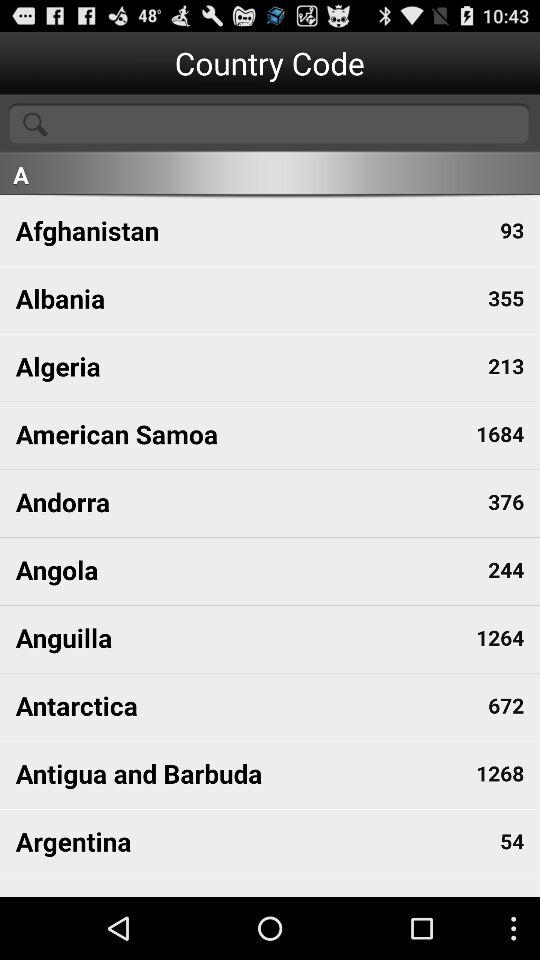Which country has the country code 93? The country is Afghanistan. 